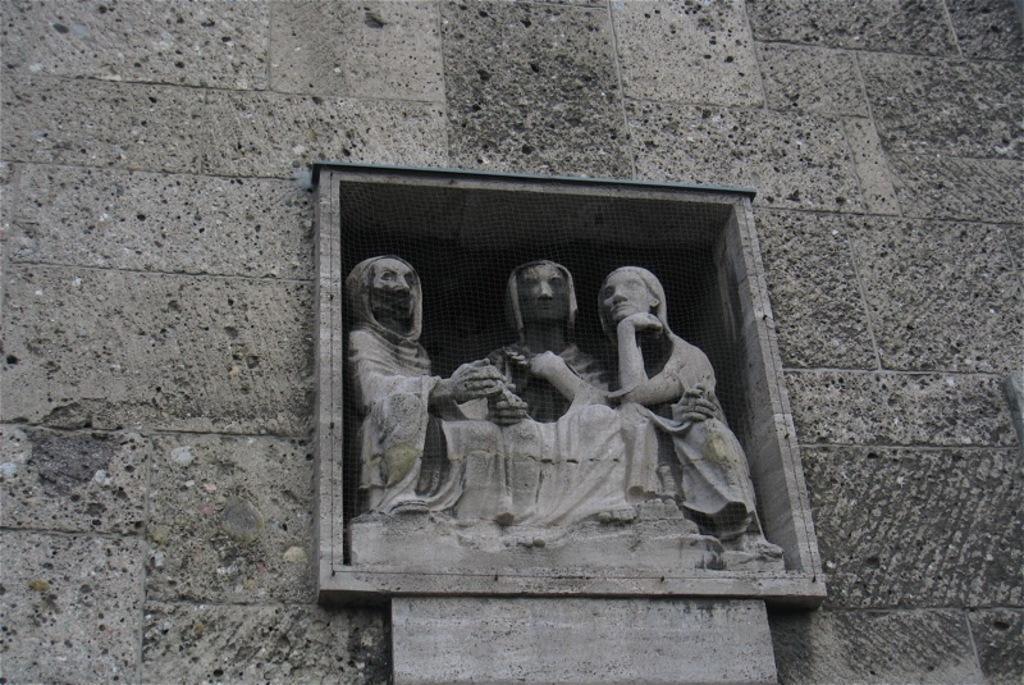Describe this image in one or two sentences. In this picture we can see sculptures, in the background there is a wall. 